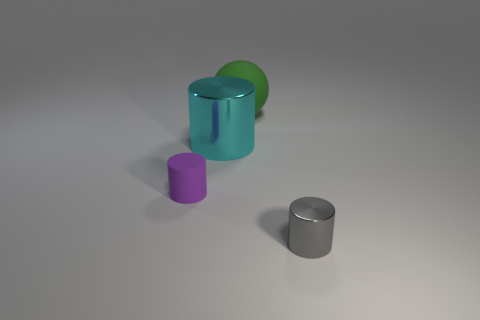Add 2 large purple objects. How many objects exist? 6 Subtract all cylinders. How many objects are left? 1 Add 4 blue metallic objects. How many blue metallic objects exist? 4 Subtract 0 red cubes. How many objects are left? 4 Subtract all shiny cylinders. Subtract all brown matte things. How many objects are left? 2 Add 2 tiny gray things. How many tiny gray things are left? 3 